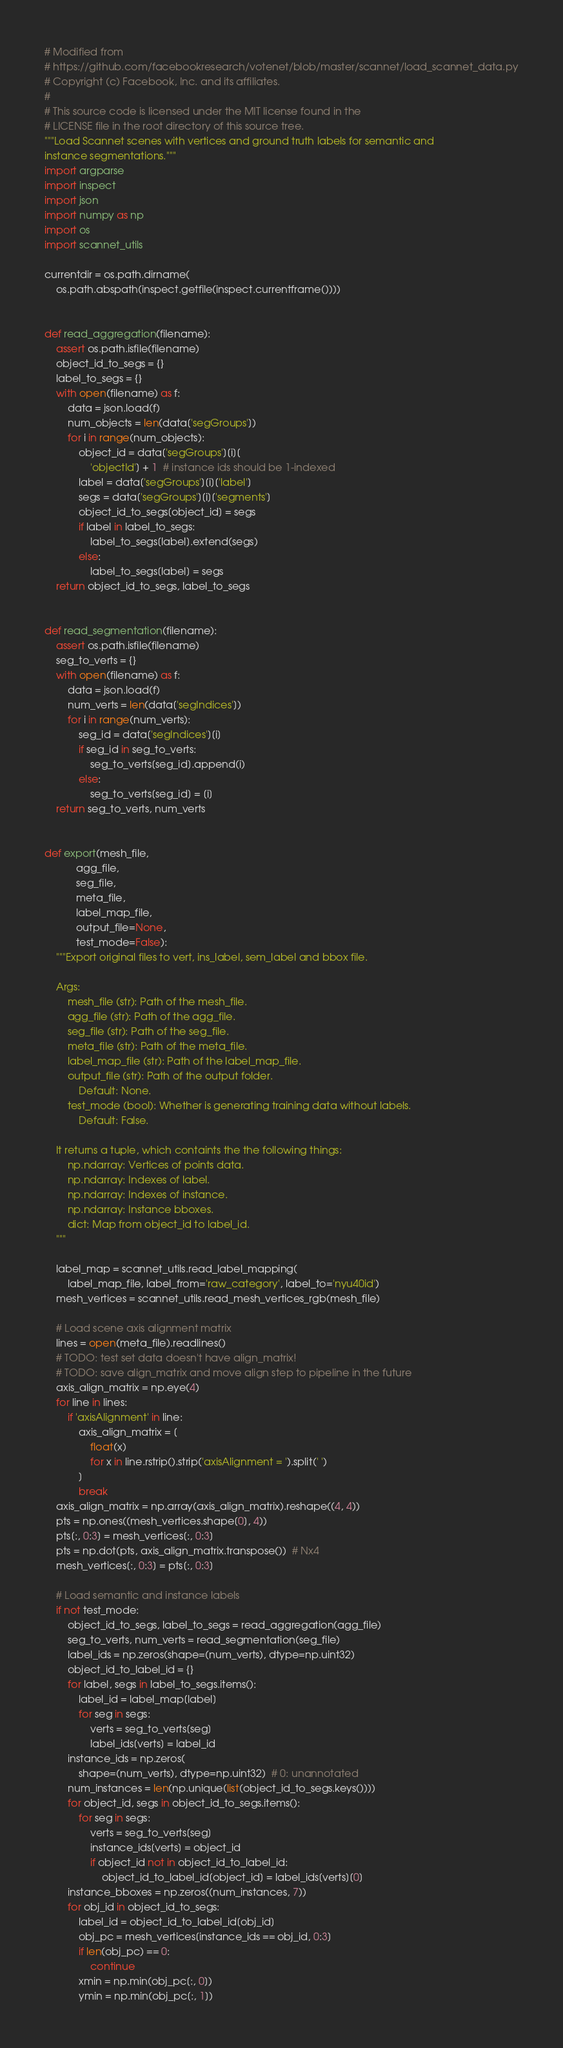Convert code to text. <code><loc_0><loc_0><loc_500><loc_500><_Python_># Modified from
# https://github.com/facebookresearch/votenet/blob/master/scannet/load_scannet_data.py
# Copyright (c) Facebook, Inc. and its affiliates.
#
# This source code is licensed under the MIT license found in the
# LICENSE file in the root directory of this source tree.
"""Load Scannet scenes with vertices and ground truth labels for semantic and
instance segmentations."""
import argparse
import inspect
import json
import numpy as np
import os
import scannet_utils

currentdir = os.path.dirname(
    os.path.abspath(inspect.getfile(inspect.currentframe())))


def read_aggregation(filename):
    assert os.path.isfile(filename)
    object_id_to_segs = {}
    label_to_segs = {}
    with open(filename) as f:
        data = json.load(f)
        num_objects = len(data['segGroups'])
        for i in range(num_objects):
            object_id = data['segGroups'][i][
                'objectId'] + 1  # instance ids should be 1-indexed
            label = data['segGroups'][i]['label']
            segs = data['segGroups'][i]['segments']
            object_id_to_segs[object_id] = segs
            if label in label_to_segs:
                label_to_segs[label].extend(segs)
            else:
                label_to_segs[label] = segs
    return object_id_to_segs, label_to_segs


def read_segmentation(filename):
    assert os.path.isfile(filename)
    seg_to_verts = {}
    with open(filename) as f:
        data = json.load(f)
        num_verts = len(data['segIndices'])
        for i in range(num_verts):
            seg_id = data['segIndices'][i]
            if seg_id in seg_to_verts:
                seg_to_verts[seg_id].append(i)
            else:
                seg_to_verts[seg_id] = [i]
    return seg_to_verts, num_verts


def export(mesh_file,
           agg_file,
           seg_file,
           meta_file,
           label_map_file,
           output_file=None,
           test_mode=False):
    """Export original files to vert, ins_label, sem_label and bbox file.

    Args:
        mesh_file (str): Path of the mesh_file.
        agg_file (str): Path of the agg_file.
        seg_file (str): Path of the seg_file.
        meta_file (str): Path of the meta_file.
        label_map_file (str): Path of the label_map_file.
        output_file (str): Path of the output folder.
            Default: None.
        test_mode (bool): Whether is generating training data without labels.
            Default: False.

    It returns a tuple, which containts the the following things:
        np.ndarray: Vertices of points data.
        np.ndarray: Indexes of label.
        np.ndarray: Indexes of instance.
        np.ndarray: Instance bboxes.
        dict: Map from object_id to label_id.
    """

    label_map = scannet_utils.read_label_mapping(
        label_map_file, label_from='raw_category', label_to='nyu40id')
    mesh_vertices = scannet_utils.read_mesh_vertices_rgb(mesh_file)

    # Load scene axis alignment matrix
    lines = open(meta_file).readlines()
    # TODO: test set data doesn't have align_matrix!
    # TODO: save align_matrix and move align step to pipeline in the future
    axis_align_matrix = np.eye(4)
    for line in lines:
        if 'axisAlignment' in line:
            axis_align_matrix = [
                float(x)
                for x in line.rstrip().strip('axisAlignment = ').split(' ')
            ]
            break
    axis_align_matrix = np.array(axis_align_matrix).reshape((4, 4))
    pts = np.ones((mesh_vertices.shape[0], 4))
    pts[:, 0:3] = mesh_vertices[:, 0:3]
    pts = np.dot(pts, axis_align_matrix.transpose())  # Nx4
    mesh_vertices[:, 0:3] = pts[:, 0:3]

    # Load semantic and instance labels
    if not test_mode:
        object_id_to_segs, label_to_segs = read_aggregation(agg_file)
        seg_to_verts, num_verts = read_segmentation(seg_file)
        label_ids = np.zeros(shape=(num_verts), dtype=np.uint32)
        object_id_to_label_id = {}
        for label, segs in label_to_segs.items():
            label_id = label_map[label]
            for seg in segs:
                verts = seg_to_verts[seg]
                label_ids[verts] = label_id
        instance_ids = np.zeros(
            shape=(num_verts), dtype=np.uint32)  # 0: unannotated
        num_instances = len(np.unique(list(object_id_to_segs.keys())))
        for object_id, segs in object_id_to_segs.items():
            for seg in segs:
                verts = seg_to_verts[seg]
                instance_ids[verts] = object_id
                if object_id not in object_id_to_label_id:
                    object_id_to_label_id[object_id] = label_ids[verts][0]
        instance_bboxes = np.zeros((num_instances, 7))
        for obj_id in object_id_to_segs:
            label_id = object_id_to_label_id[obj_id]
            obj_pc = mesh_vertices[instance_ids == obj_id, 0:3]
            if len(obj_pc) == 0:
                continue
            xmin = np.min(obj_pc[:, 0])
            ymin = np.min(obj_pc[:, 1])</code> 